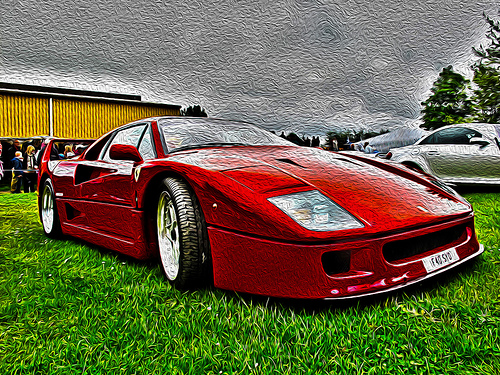<image>
Can you confirm if the car is in the grass? Yes. The car is contained within or inside the grass, showing a containment relationship. Where is the tire in relation to the grass? Is it on the grass? Yes. Looking at the image, I can see the tire is positioned on top of the grass, with the grass providing support. Is the red car in front of the silver car? Yes. The red car is positioned in front of the silver car, appearing closer to the camera viewpoint. 